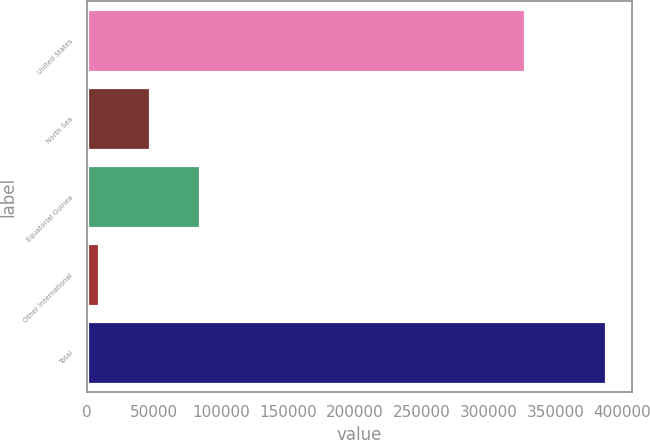Convert chart to OTSL. <chart><loc_0><loc_0><loc_500><loc_500><bar_chart><fcel>United States<fcel>North Sea<fcel>Equatorial Guinea<fcel>Other International<fcel>Total<nl><fcel>327451<fcel>46681.4<fcel>84563.8<fcel>8799<fcel>387623<nl></chart> 